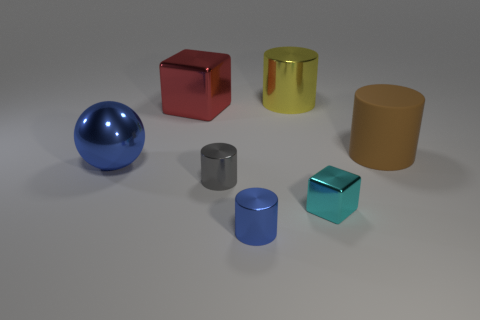Is there anything else of the same color as the big metal cube?
Give a very brief answer. No. What is the shape of the large red object that is the same material as the big blue sphere?
Make the answer very short. Cube. What is the color of the block that is in front of the tiny metal cylinder on the left side of the blue shiny object that is to the right of the red object?
Your answer should be very brief. Cyan. Are there the same number of big things that are on the left side of the red shiny object and brown rubber cylinders?
Offer a terse response. Yes. Are there any other things that have the same material as the large brown thing?
Provide a short and direct response. No. There is a big ball; does it have the same color as the metallic cylinder that is in front of the gray shiny object?
Provide a short and direct response. Yes. Are there any large metal objects that are behind the blue thing behind the block that is in front of the brown rubber cylinder?
Ensure brevity in your answer.  Yes. Is the number of yellow shiny objects on the left side of the cyan block less than the number of tiny brown cubes?
Your response must be concise. No. How many other objects are there of the same shape as the gray thing?
Keep it short and to the point. 3. How many objects are objects in front of the matte thing or blue metal things in front of the metallic sphere?
Your response must be concise. 4. 